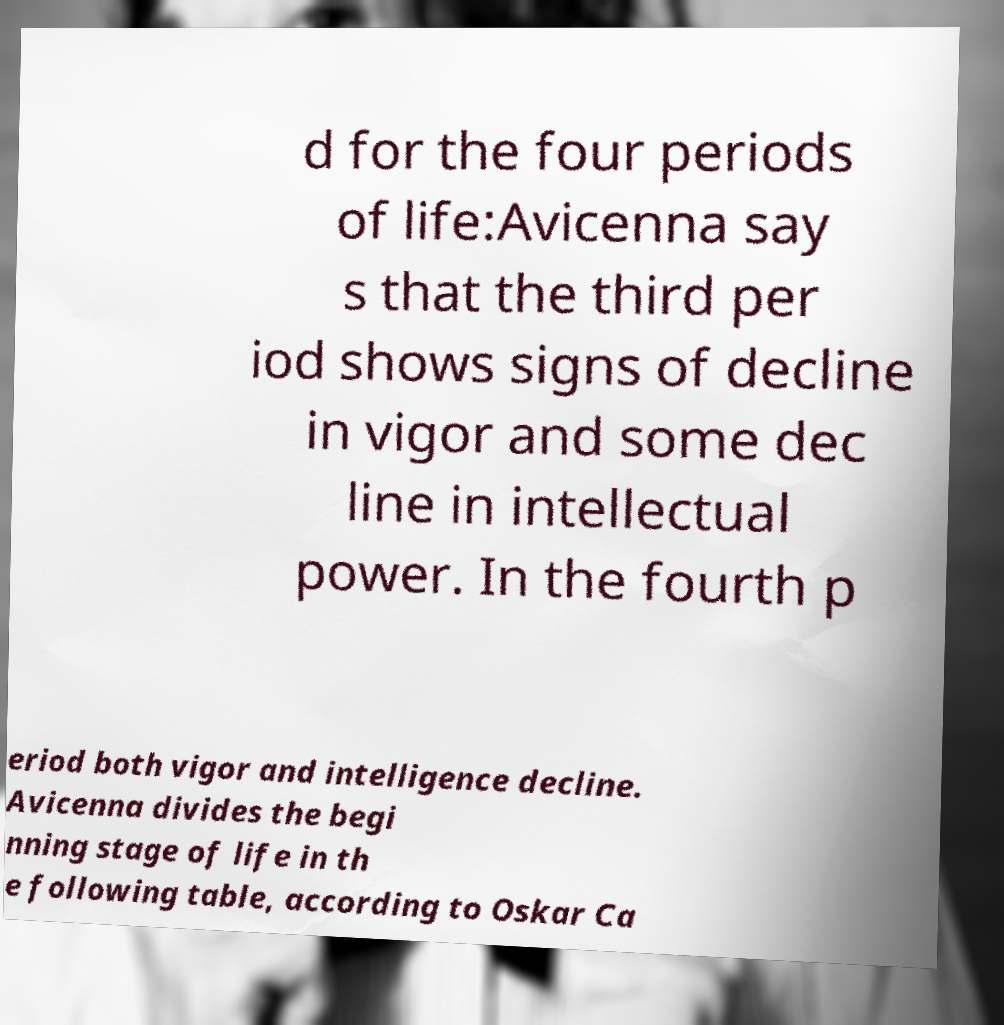For documentation purposes, I need the text within this image transcribed. Could you provide that? d for the four periods of life:Avicenna say s that the third per iod shows signs of decline in vigor and some dec line in intellectual power. In the fourth p eriod both vigor and intelligence decline. Avicenna divides the begi nning stage of life in th e following table, according to Oskar Ca 